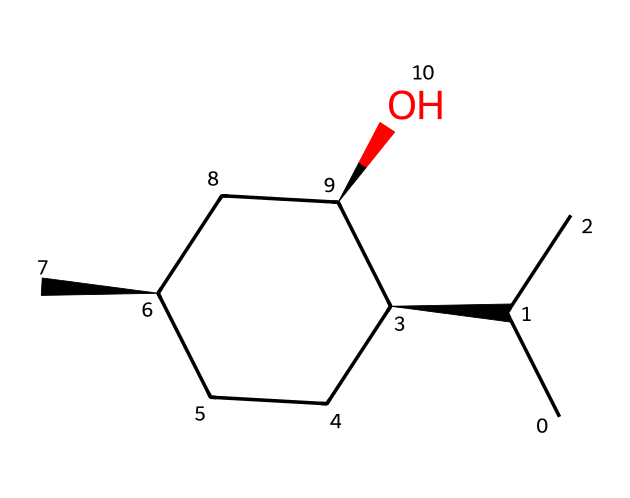What is the name of this chiral compound? The SMILES representation corresponds to menthol, which is a well-known chiral compound commonly found in mint-flavored products.
Answer: menthol How many carbon atoms are in this structure? By analyzing the SMILES representation, we can count the carbon atoms listed. In this case, there are ten carbon atoms indicated in the structure.
Answer: ten What type of functional group is present in menthol? The structure includes a hydroxyl group (-OH) connected to one of the carbon atoms, which characterizes menthol as an alcohol.
Answer: alcohol How many chiral centers are present in menthol? A chiral center is indicated by a carbon atom bonded to four different groups. By examining the structure, it is determined that menthol has three such chiral centers.
Answer: three What physical property is influenced by the chirality of menthol? Chirality affects the way molecules interact with polarized light, leading to optical activity, which means menthol can rotate plane-polarized light in a specific direction.
Answer: optical activity Which enantiomer of menthol is typically used in cocktails? The common enantiomer used in cocktails and mint flavors is the (R)-menthol, which provides the characteristic minty flavor and aroma.
Answer: (R)-menthol How does the presence of the -OH group affect the solubility of menthol? The hydroxyl group increases the polarity of menthol, enhancing its solubility in water compared to non-alcoholic hydrocarbons.
Answer: increases solubility 